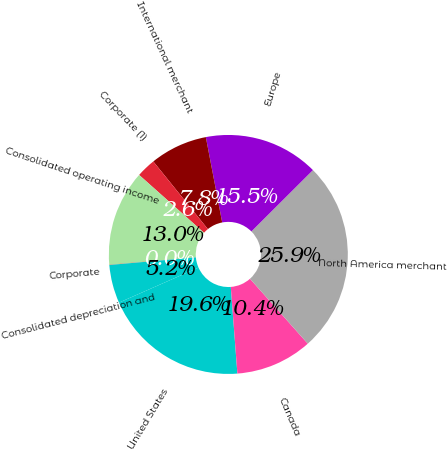Convert chart. <chart><loc_0><loc_0><loc_500><loc_500><pie_chart><fcel>United States<fcel>Canada<fcel>North America merchant<fcel>Europe<fcel>International merchant<fcel>Corporate (1)<fcel>Consolidated operating income<fcel>Corporate<fcel>Consolidated depreciation and<nl><fcel>19.6%<fcel>10.37%<fcel>25.89%<fcel>15.54%<fcel>7.79%<fcel>2.61%<fcel>12.96%<fcel>0.03%<fcel>5.2%<nl></chart> 